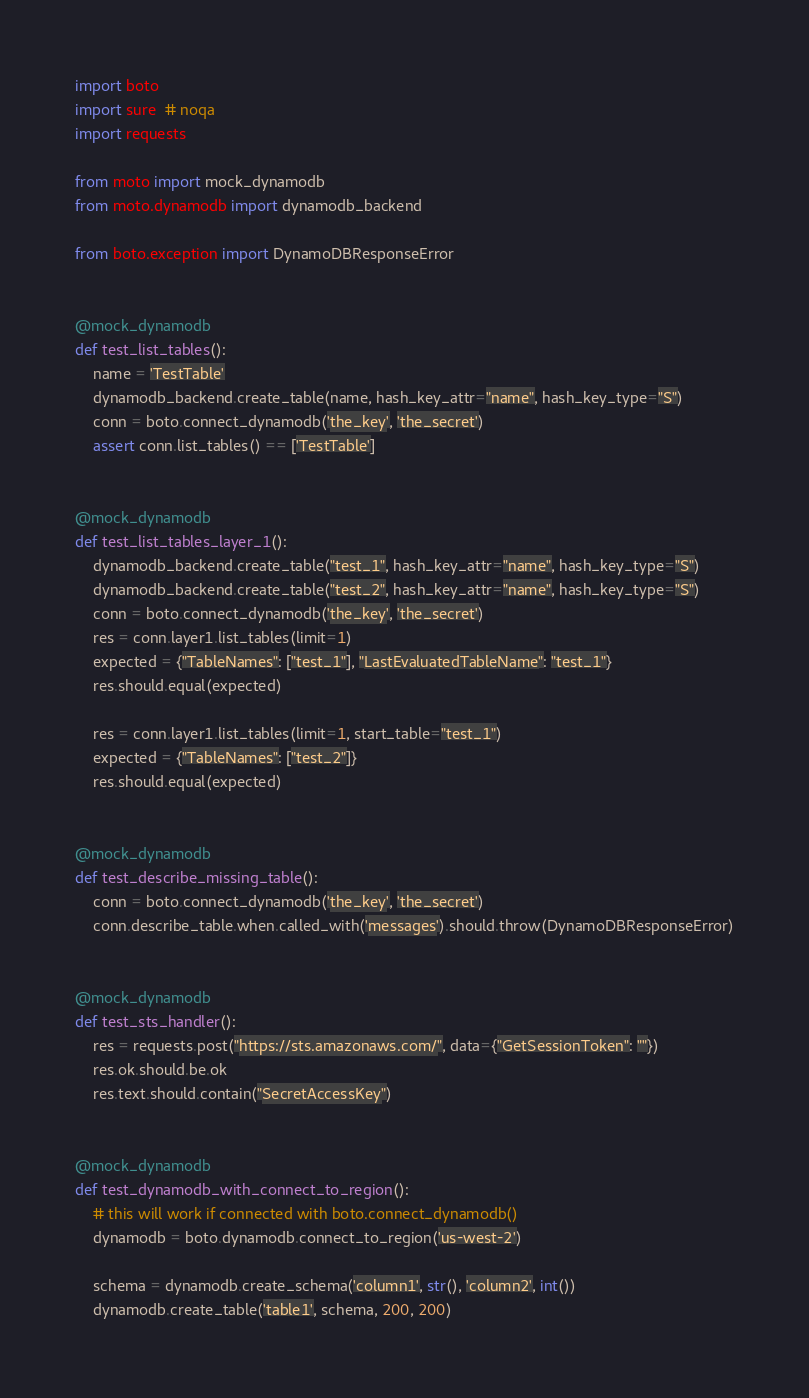<code> <loc_0><loc_0><loc_500><loc_500><_Python_>import boto
import sure  # noqa
import requests

from moto import mock_dynamodb
from moto.dynamodb import dynamodb_backend

from boto.exception import DynamoDBResponseError


@mock_dynamodb
def test_list_tables():
    name = 'TestTable'
    dynamodb_backend.create_table(name, hash_key_attr="name", hash_key_type="S")
    conn = boto.connect_dynamodb('the_key', 'the_secret')
    assert conn.list_tables() == ['TestTable']


@mock_dynamodb
def test_list_tables_layer_1():
    dynamodb_backend.create_table("test_1", hash_key_attr="name", hash_key_type="S")
    dynamodb_backend.create_table("test_2", hash_key_attr="name", hash_key_type="S")
    conn = boto.connect_dynamodb('the_key', 'the_secret')
    res = conn.layer1.list_tables(limit=1)
    expected = {"TableNames": ["test_1"], "LastEvaluatedTableName": "test_1"}
    res.should.equal(expected)

    res = conn.layer1.list_tables(limit=1, start_table="test_1")
    expected = {"TableNames": ["test_2"]}
    res.should.equal(expected)


@mock_dynamodb
def test_describe_missing_table():
    conn = boto.connect_dynamodb('the_key', 'the_secret')
    conn.describe_table.when.called_with('messages').should.throw(DynamoDBResponseError)


@mock_dynamodb
def test_sts_handler():
    res = requests.post("https://sts.amazonaws.com/", data={"GetSessionToken": ""})
    res.ok.should.be.ok
    res.text.should.contain("SecretAccessKey")


@mock_dynamodb
def test_dynamodb_with_connect_to_region():
    # this will work if connected with boto.connect_dynamodb()
    dynamodb = boto.dynamodb.connect_to_region('us-west-2')

    schema = dynamodb.create_schema('column1', str(), 'column2', int())
    dynamodb.create_table('table1', schema, 200, 200)
</code> 